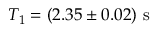Convert formula to latex. <formula><loc_0><loc_0><loc_500><loc_500>{ T _ { 1 } = ( 2 . 3 5 \pm 0 . 0 2 ) s }</formula> 